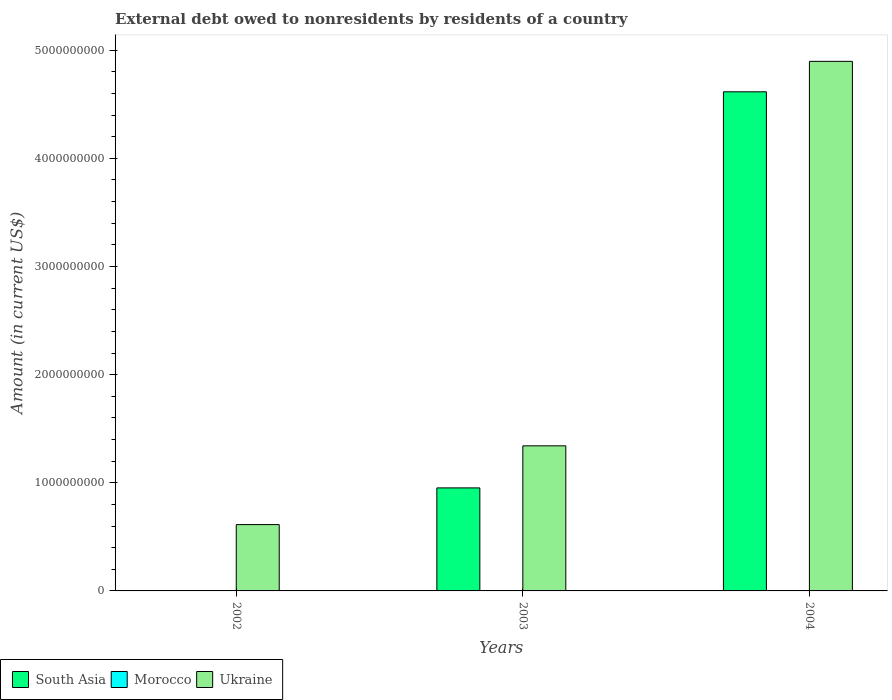Are the number of bars per tick equal to the number of legend labels?
Give a very brief answer. No. Are the number of bars on each tick of the X-axis equal?
Make the answer very short. No. What is the external debt owed by residents in Ukraine in 2002?
Offer a very short reply. 6.13e+08. Across all years, what is the maximum external debt owed by residents in Ukraine?
Keep it short and to the point. 4.90e+09. In which year was the external debt owed by residents in South Asia maximum?
Keep it short and to the point. 2004. What is the total external debt owed by residents in South Asia in the graph?
Provide a succinct answer. 5.57e+09. What is the difference between the external debt owed by residents in Ukraine in 2002 and that in 2004?
Ensure brevity in your answer.  -4.28e+09. What is the difference between the external debt owed by residents in South Asia in 2003 and the external debt owed by residents in Morocco in 2002?
Your answer should be compact. 9.53e+08. What is the average external debt owed by residents in Ukraine per year?
Your answer should be very brief. 2.28e+09. In the year 2004, what is the difference between the external debt owed by residents in South Asia and external debt owed by residents in Ukraine?
Provide a short and direct response. -2.82e+08. Is the external debt owed by residents in Ukraine in 2002 less than that in 2004?
Ensure brevity in your answer.  Yes. What is the difference between the highest and the second highest external debt owed by residents in Ukraine?
Your answer should be very brief. 3.56e+09. What is the difference between the highest and the lowest external debt owed by residents in Ukraine?
Your response must be concise. 4.28e+09. In how many years, is the external debt owed by residents in Ukraine greater than the average external debt owed by residents in Ukraine taken over all years?
Make the answer very short. 1. Is the sum of the external debt owed by residents in South Asia in 2003 and 2004 greater than the maximum external debt owed by residents in Morocco across all years?
Your answer should be compact. Yes. What is the difference between two consecutive major ticks on the Y-axis?
Ensure brevity in your answer.  1.00e+09. How many legend labels are there?
Your answer should be very brief. 3. How are the legend labels stacked?
Your response must be concise. Horizontal. What is the title of the graph?
Make the answer very short. External debt owed to nonresidents by residents of a country. Does "South Sudan" appear as one of the legend labels in the graph?
Give a very brief answer. No. What is the label or title of the X-axis?
Keep it short and to the point. Years. What is the Amount (in current US$) of South Asia in 2002?
Keep it short and to the point. 0. What is the Amount (in current US$) in Morocco in 2002?
Make the answer very short. 0. What is the Amount (in current US$) in Ukraine in 2002?
Your answer should be very brief. 6.13e+08. What is the Amount (in current US$) in South Asia in 2003?
Your response must be concise. 9.53e+08. What is the Amount (in current US$) of Ukraine in 2003?
Give a very brief answer. 1.34e+09. What is the Amount (in current US$) of South Asia in 2004?
Make the answer very short. 4.62e+09. What is the Amount (in current US$) in Morocco in 2004?
Make the answer very short. 0. What is the Amount (in current US$) of Ukraine in 2004?
Your answer should be compact. 4.90e+09. Across all years, what is the maximum Amount (in current US$) in South Asia?
Provide a short and direct response. 4.62e+09. Across all years, what is the maximum Amount (in current US$) of Ukraine?
Ensure brevity in your answer.  4.90e+09. Across all years, what is the minimum Amount (in current US$) of South Asia?
Keep it short and to the point. 0. Across all years, what is the minimum Amount (in current US$) in Ukraine?
Your response must be concise. 6.13e+08. What is the total Amount (in current US$) of South Asia in the graph?
Keep it short and to the point. 5.57e+09. What is the total Amount (in current US$) of Morocco in the graph?
Provide a succinct answer. 0. What is the total Amount (in current US$) in Ukraine in the graph?
Your response must be concise. 6.85e+09. What is the difference between the Amount (in current US$) of Ukraine in 2002 and that in 2003?
Keep it short and to the point. -7.28e+08. What is the difference between the Amount (in current US$) of Ukraine in 2002 and that in 2004?
Make the answer very short. -4.28e+09. What is the difference between the Amount (in current US$) of South Asia in 2003 and that in 2004?
Your answer should be compact. -3.66e+09. What is the difference between the Amount (in current US$) in Ukraine in 2003 and that in 2004?
Give a very brief answer. -3.56e+09. What is the difference between the Amount (in current US$) in South Asia in 2003 and the Amount (in current US$) in Ukraine in 2004?
Provide a succinct answer. -3.94e+09. What is the average Amount (in current US$) of South Asia per year?
Keep it short and to the point. 1.86e+09. What is the average Amount (in current US$) in Morocco per year?
Keep it short and to the point. 0. What is the average Amount (in current US$) in Ukraine per year?
Your response must be concise. 2.28e+09. In the year 2003, what is the difference between the Amount (in current US$) of South Asia and Amount (in current US$) of Ukraine?
Offer a terse response. -3.89e+08. In the year 2004, what is the difference between the Amount (in current US$) in South Asia and Amount (in current US$) in Ukraine?
Your answer should be very brief. -2.82e+08. What is the ratio of the Amount (in current US$) of Ukraine in 2002 to that in 2003?
Give a very brief answer. 0.46. What is the ratio of the Amount (in current US$) of Ukraine in 2002 to that in 2004?
Your response must be concise. 0.13. What is the ratio of the Amount (in current US$) in South Asia in 2003 to that in 2004?
Your answer should be compact. 0.21. What is the ratio of the Amount (in current US$) of Ukraine in 2003 to that in 2004?
Ensure brevity in your answer.  0.27. What is the difference between the highest and the second highest Amount (in current US$) in Ukraine?
Offer a very short reply. 3.56e+09. What is the difference between the highest and the lowest Amount (in current US$) in South Asia?
Keep it short and to the point. 4.62e+09. What is the difference between the highest and the lowest Amount (in current US$) of Ukraine?
Your answer should be very brief. 4.28e+09. 